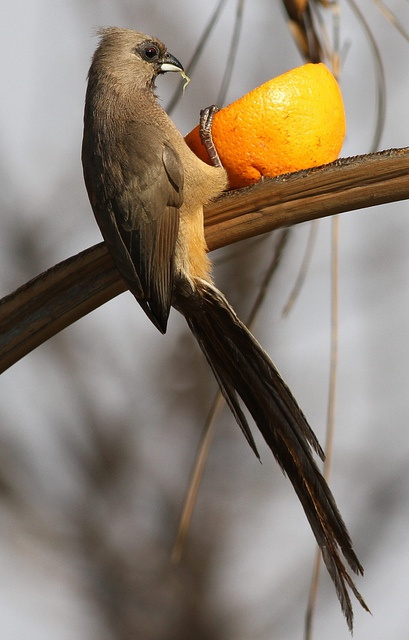Describe the objects in this image and their specific colors. I can see bird in lightgray, black, maroon, and gray tones and orange in lightgray, orange, gold, and red tones in this image. 